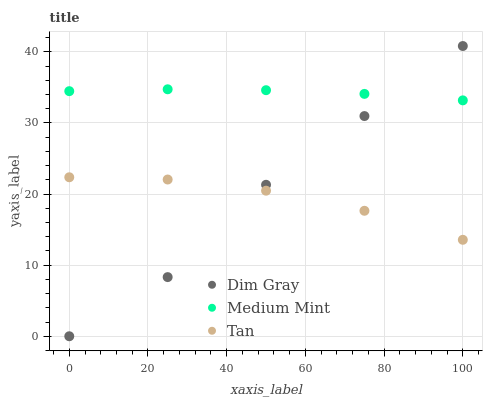Does Tan have the minimum area under the curve?
Answer yes or no. Yes. Does Medium Mint have the maximum area under the curve?
Answer yes or no. Yes. Does Dim Gray have the minimum area under the curve?
Answer yes or no. No. Does Dim Gray have the maximum area under the curve?
Answer yes or no. No. Is Medium Mint the smoothest?
Answer yes or no. Yes. Is Dim Gray the roughest?
Answer yes or no. Yes. Is Tan the smoothest?
Answer yes or no. No. Is Tan the roughest?
Answer yes or no. No. Does Dim Gray have the lowest value?
Answer yes or no. Yes. Does Tan have the lowest value?
Answer yes or no. No. Does Dim Gray have the highest value?
Answer yes or no. Yes. Does Tan have the highest value?
Answer yes or no. No. Is Tan less than Medium Mint?
Answer yes or no. Yes. Is Medium Mint greater than Tan?
Answer yes or no. Yes. Does Dim Gray intersect Medium Mint?
Answer yes or no. Yes. Is Dim Gray less than Medium Mint?
Answer yes or no. No. Is Dim Gray greater than Medium Mint?
Answer yes or no. No. Does Tan intersect Medium Mint?
Answer yes or no. No. 